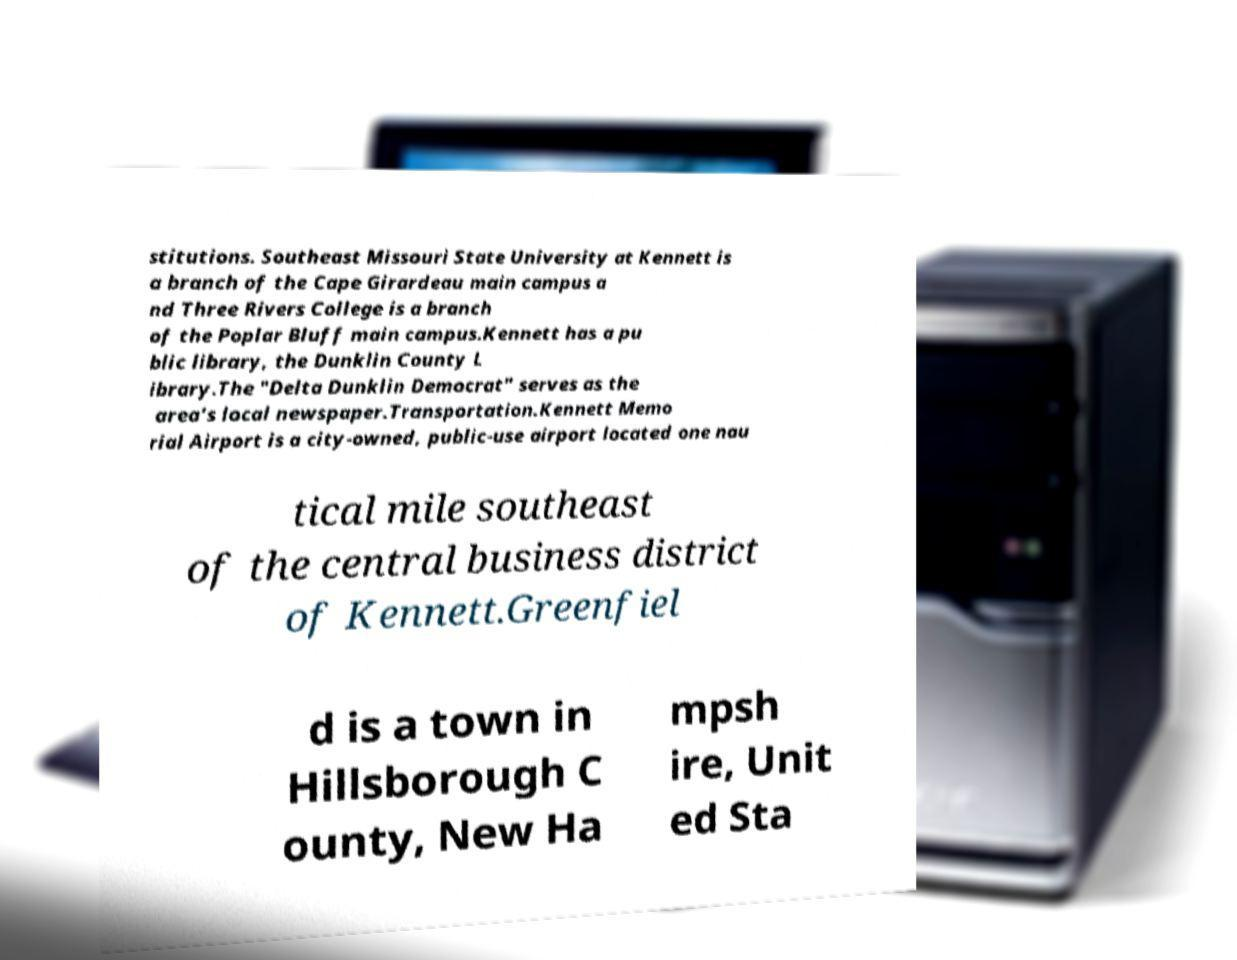Please identify and transcribe the text found in this image. stitutions. Southeast Missouri State University at Kennett is a branch of the Cape Girardeau main campus a nd Three Rivers College is a branch of the Poplar Bluff main campus.Kennett has a pu blic library, the Dunklin County L ibrary.The "Delta Dunklin Democrat" serves as the area's local newspaper.Transportation.Kennett Memo rial Airport is a city-owned, public-use airport located one nau tical mile southeast of the central business district of Kennett.Greenfiel d is a town in Hillsborough C ounty, New Ha mpsh ire, Unit ed Sta 